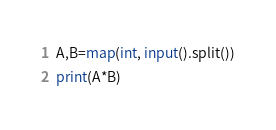Convert code to text. <code><loc_0><loc_0><loc_500><loc_500><_Python_>A,B=map(int, input().split())
print(A*B)</code> 